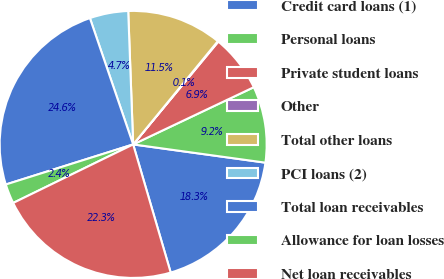Convert chart. <chart><loc_0><loc_0><loc_500><loc_500><pie_chart><fcel>Credit card loans (1)<fcel>Personal loans<fcel>Private student loans<fcel>Other<fcel>Total other loans<fcel>PCI loans (2)<fcel>Total loan receivables<fcel>Allowance for loan losses<fcel>Net loan receivables<nl><fcel>18.28%<fcel>9.23%<fcel>6.94%<fcel>0.08%<fcel>11.52%<fcel>4.66%<fcel>24.6%<fcel>2.37%<fcel>22.31%<nl></chart> 